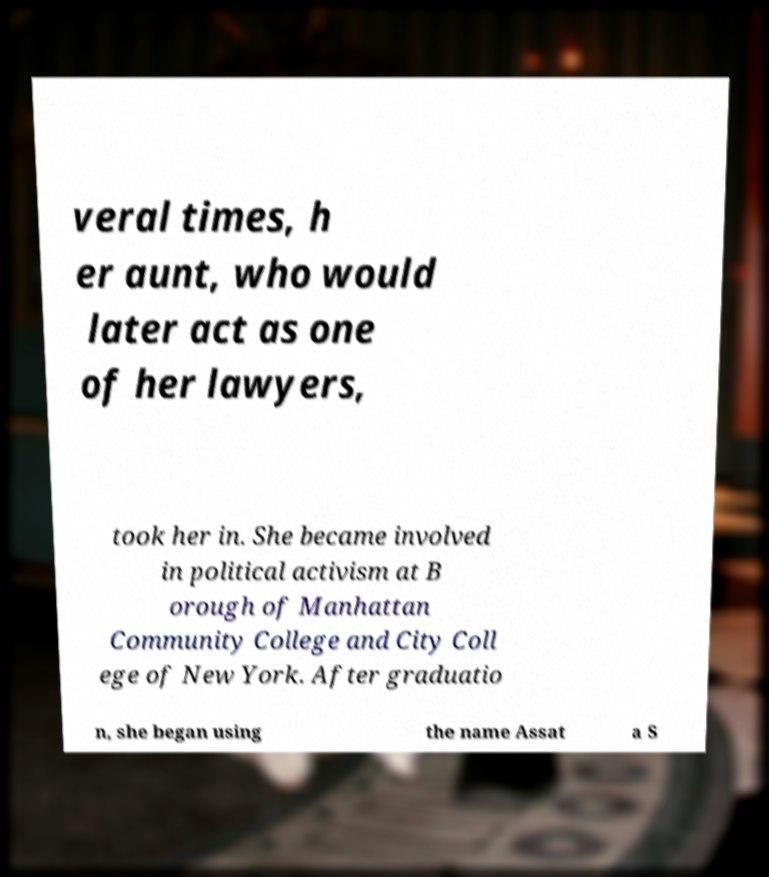Can you read and provide the text displayed in the image?This photo seems to have some interesting text. Can you extract and type it out for me? veral times, h er aunt, who would later act as one of her lawyers, took her in. She became involved in political activism at B orough of Manhattan Community College and City Coll ege of New York. After graduatio n, she began using the name Assat a S 